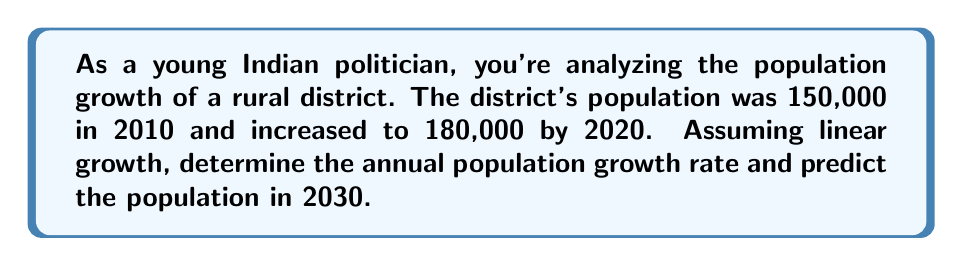Solve this math problem. Let's approach this step-by-step using a linear equation:

1) First, we'll define our variables:
   $x$ = years since 2010
   $y$ = population

2) We know two points: (0, 150,000) and (10, 180,000)

3) The linear equation has the form $y = mx + b$, where:
   $m$ = slope (annual growth rate)
   $b$ = y-intercept (initial population in 2010)

4) Calculate the slope (m):
   $$m = \frac{y_2 - y_1}{x_2 - x_1} = \frac{180,000 - 150,000}{10 - 0} = \frac{30,000}{10} = 3,000$$

5) The slope, 3,000, represents the annual population growth.

6) Now we can write our linear equation:
   $$y = 3,000x + 150,000$$

7) To predict the population in 2030, we substitute $x = 20$ (20 years after 2010):
   $$y = 3,000(20) + 150,000 = 60,000 + 150,000 = 210,000$$

8) To calculate the growth rate as a percentage:
   $$\text{Growth Rate} = \frac{\text{Annual Growth}}{\text{Initial Population}} \times 100\%$$
   $$= \frac{3,000}{150,000} \times 100\% = 2\%$$
Answer: 2% annual growth rate; 210,000 population in 2030 